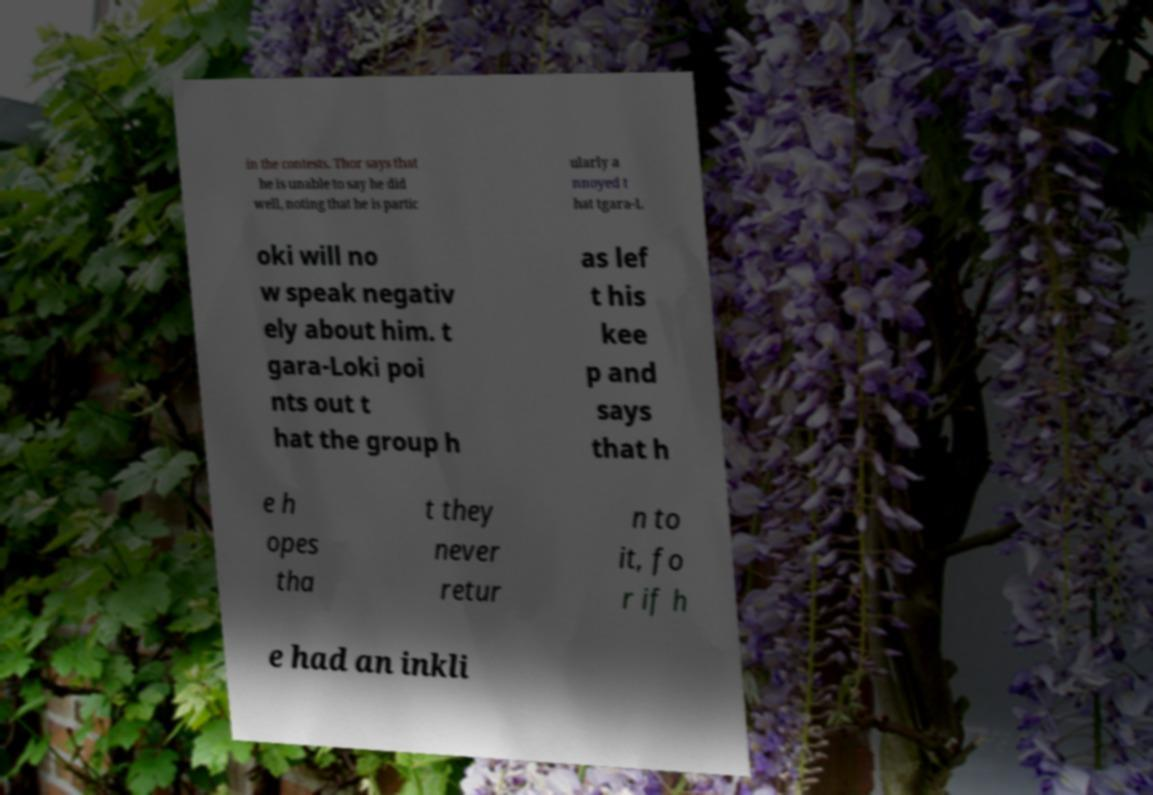Please read and relay the text visible in this image. What does it say? in the contests. Thor says that he is unable to say he did well, noting that he is partic ularly a nnoyed t hat tgara-L oki will no w speak negativ ely about him. t gara-Loki poi nts out t hat the group h as lef t his kee p and says that h e h opes tha t they never retur n to it, fo r if h e had an inkli 